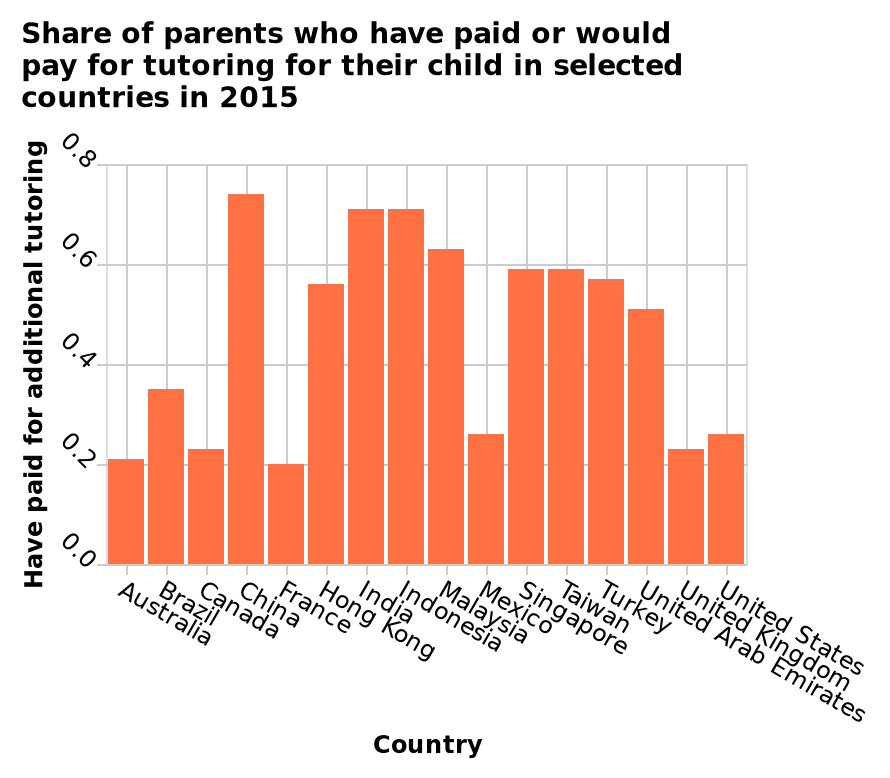<image>
Describe the following image in detail Here a is a bar diagram called Share of parents who have paid or would pay for tutoring for their child in selected countries in 2015. The x-axis measures Country while the y-axis measures Have paid for additional tutoring. What is the significance of the year 2015 in the bar diagram? The bar diagram represents the share of parents who have paid or would pay for tutoring for their child in selected countries in the year 2015. What is the title of the bar diagram? The bar diagram is titled "Share of parents who have paid or would pay for tutoring for their child in selected countries in 2015." What does the x-axis measure in the bar diagram? The x-axis in the bar diagram measures the countries. What does the y-axis measure in the bar diagram? The y-axis in the bar diagram measures the percentage of parents who have paid for additional tutoring. Which country has the highest share?  China has the highest share with approximately 0.75. 